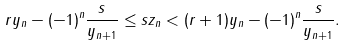<formula> <loc_0><loc_0><loc_500><loc_500>r y _ { n } - ( - 1 ) ^ { n } \frac { s } { y _ { n + 1 } } \leq s z _ { n } < ( r + 1 ) y _ { n } - ( - 1 ) ^ { n } \frac { s } { y _ { n + 1 } } .</formula> 